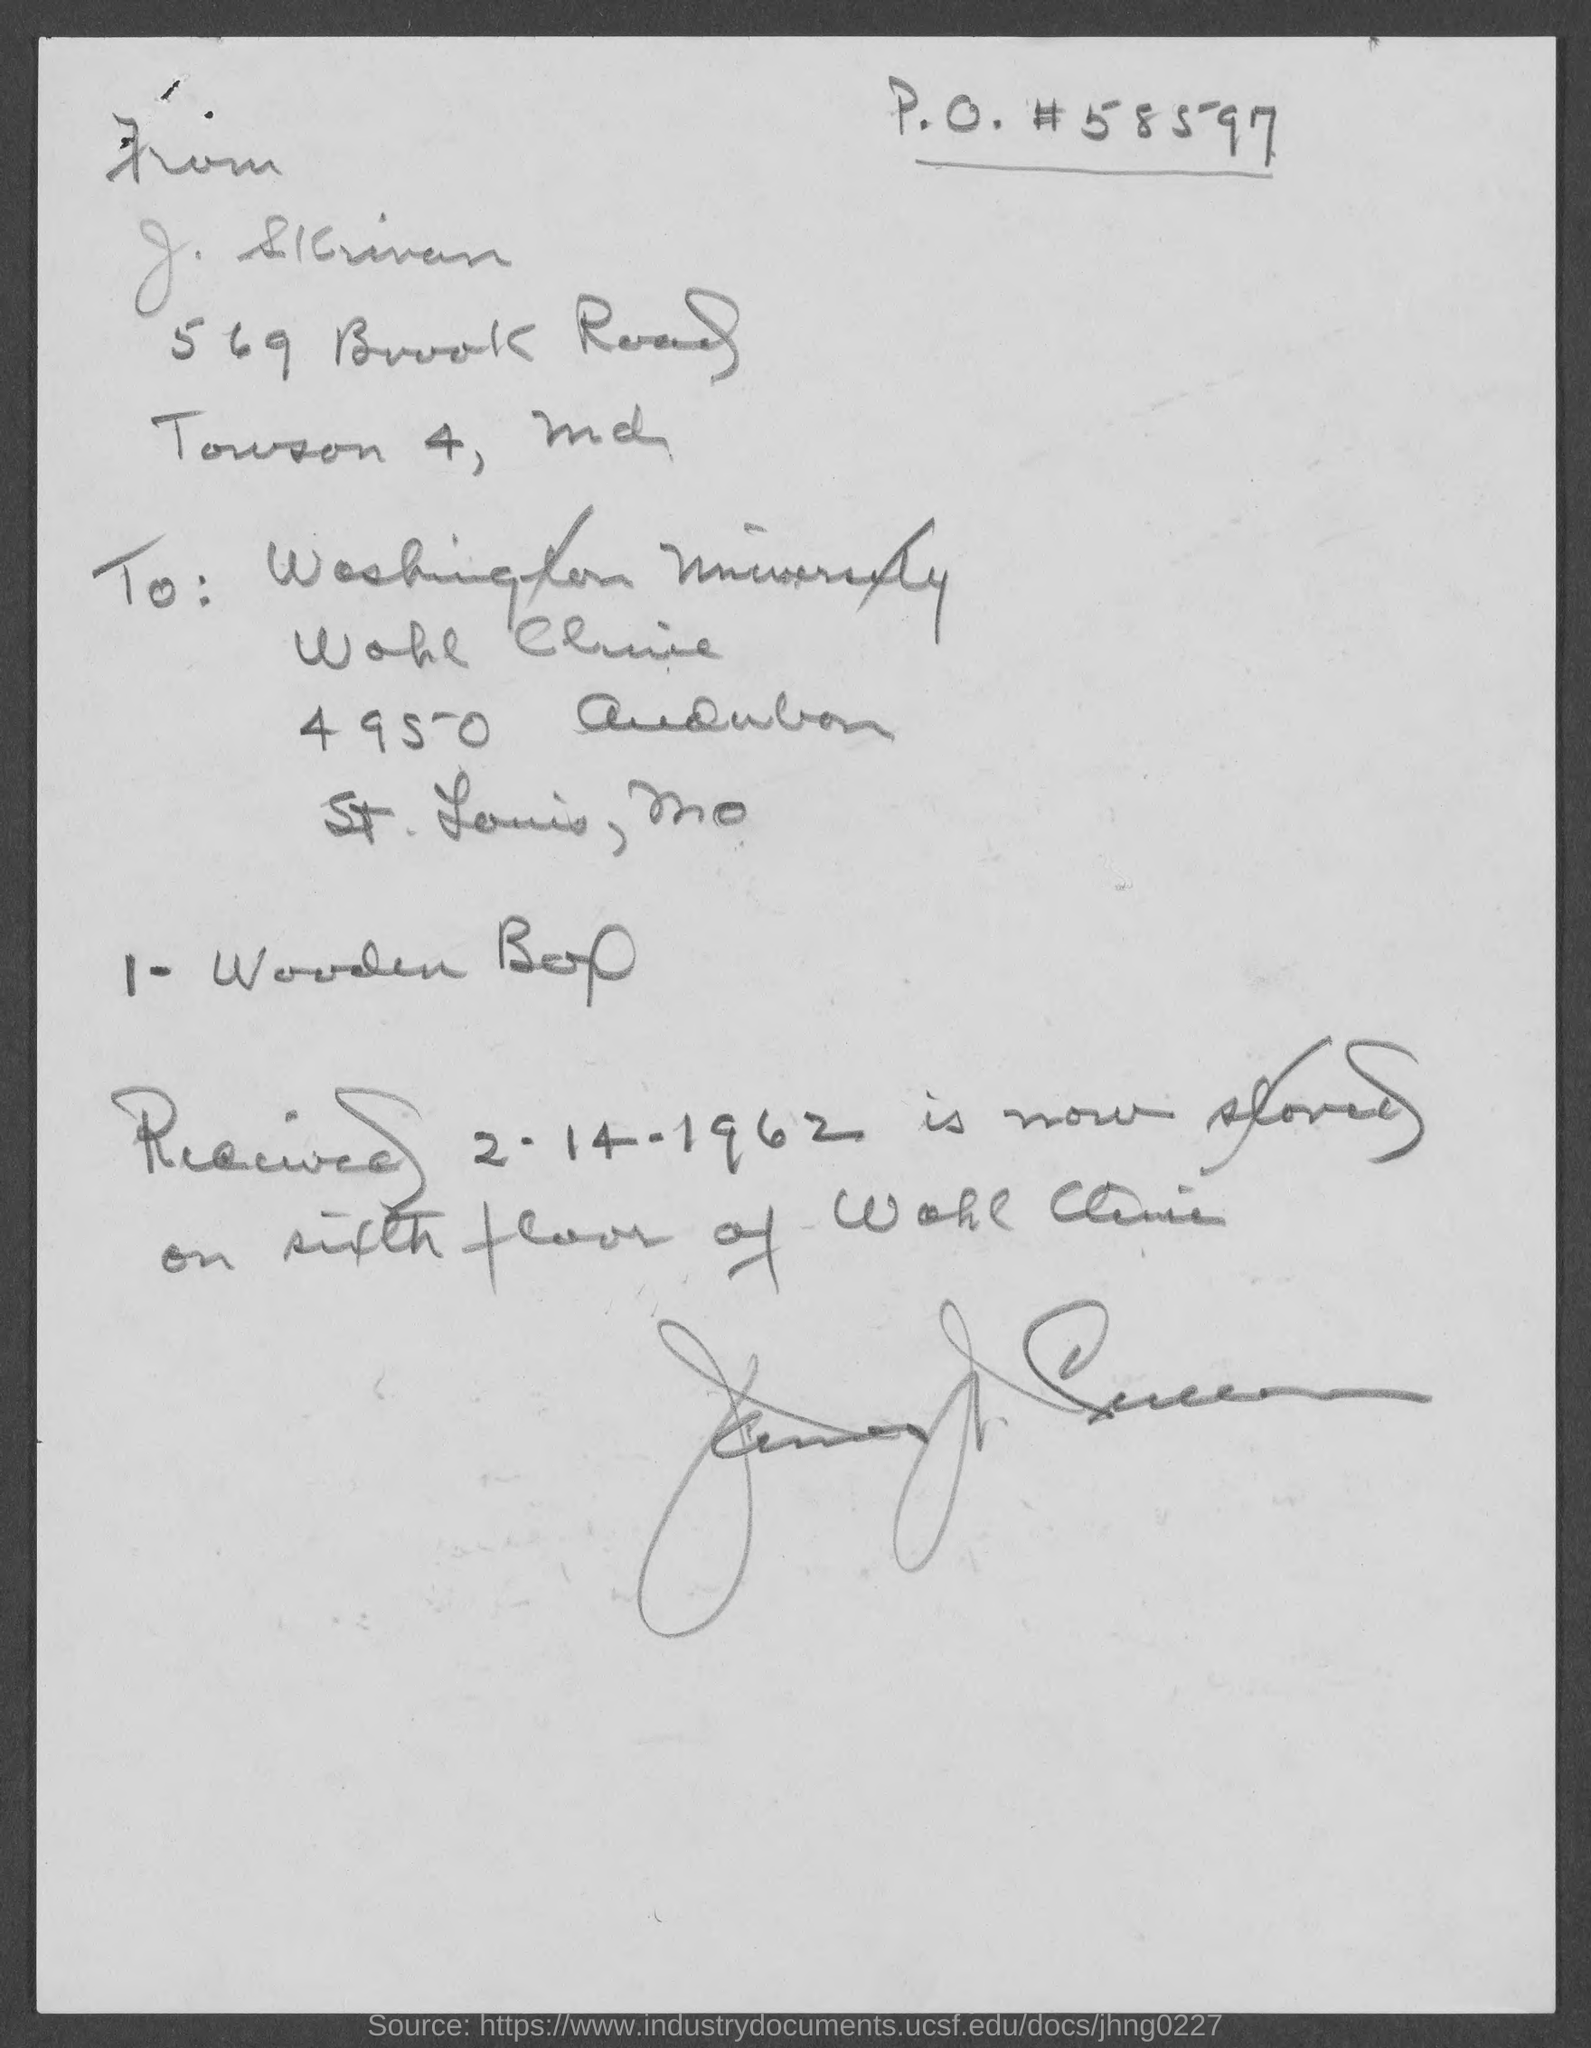To whom, the letter is addressed?
Keep it short and to the point. Washington University. What is the received date mentioned in the letter?
Offer a terse response. 2-14-1962. 